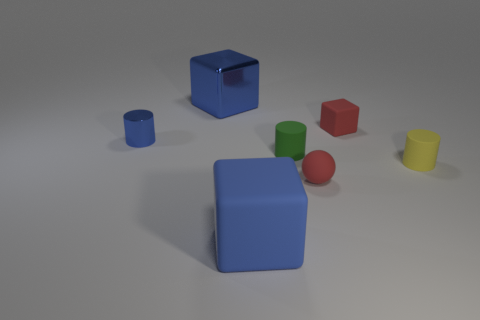What material is the thing that is the same color as the small sphere?
Give a very brief answer. Rubber. There is a blue thing in front of the tiny shiny thing; what is it made of?
Make the answer very short. Rubber. Are there any tiny matte objects of the same color as the large metallic block?
Keep it short and to the point. No. The object that is the same size as the blue matte cube is what color?
Make the answer very short. Blue. What number of large things are green matte objects or blue matte cylinders?
Offer a very short reply. 0. Are there the same number of big blue metal cubes that are left of the blue cylinder and tiny matte balls on the right side of the metal cube?
Your response must be concise. No. How many green matte things are the same size as the metallic block?
Your answer should be very brief. 0. What number of yellow objects are either large cylinders or small matte cylinders?
Your response must be concise. 1. Is the number of rubber objects that are on the right side of the blue metallic cylinder the same as the number of small yellow rubber objects?
Your answer should be compact. No. How big is the matte cube that is behind the large rubber thing?
Your answer should be compact. Small. 